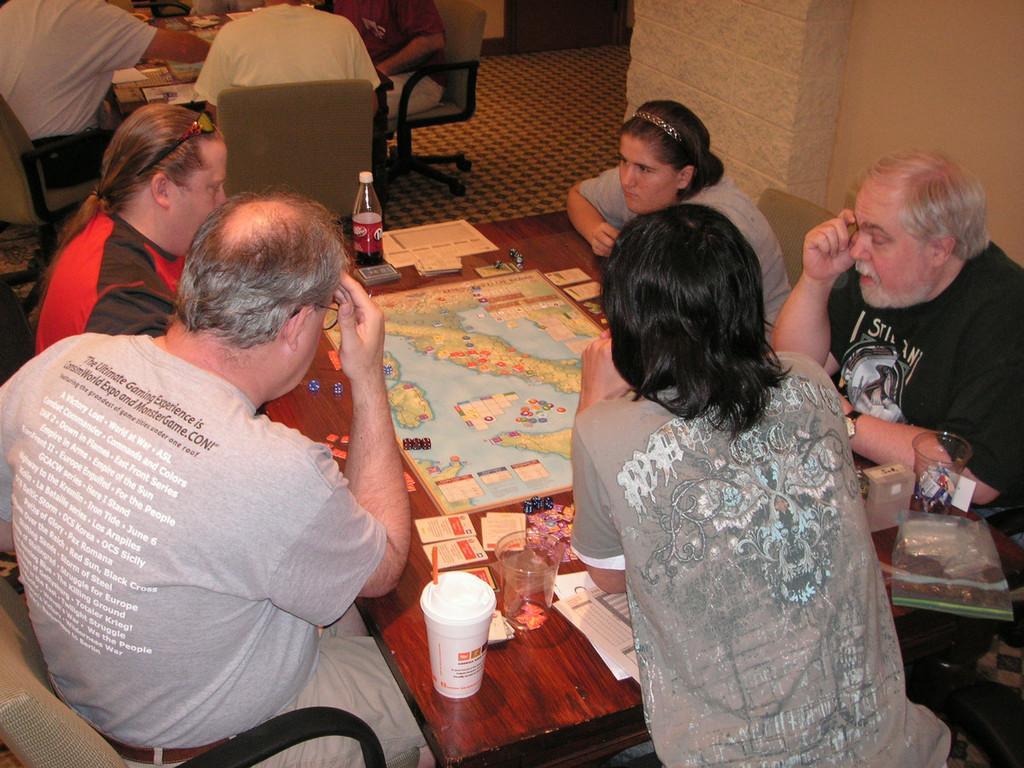Describe this image in one or two sentences. This picture describes about group of people they are seated on the chair in front of them we can find cups bottle a map on the table. 